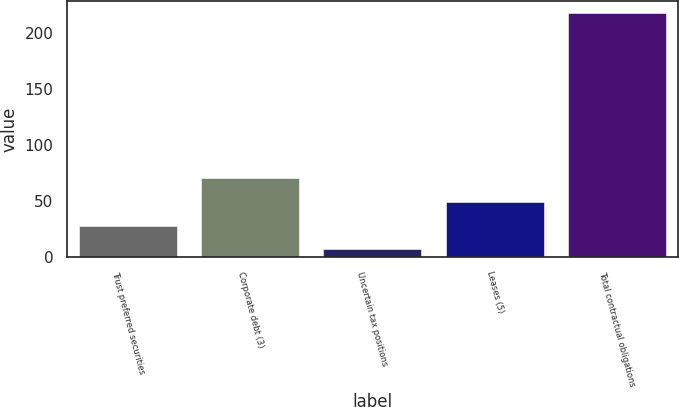<chart> <loc_0><loc_0><loc_500><loc_500><bar_chart><fcel>Trust preferred securities<fcel>Corporate debt (3)<fcel>Uncertain tax positions<fcel>Leases (5)<fcel>Total contractual obligations<nl><fcel>28.1<fcel>70.3<fcel>7<fcel>49.2<fcel>218<nl></chart> 